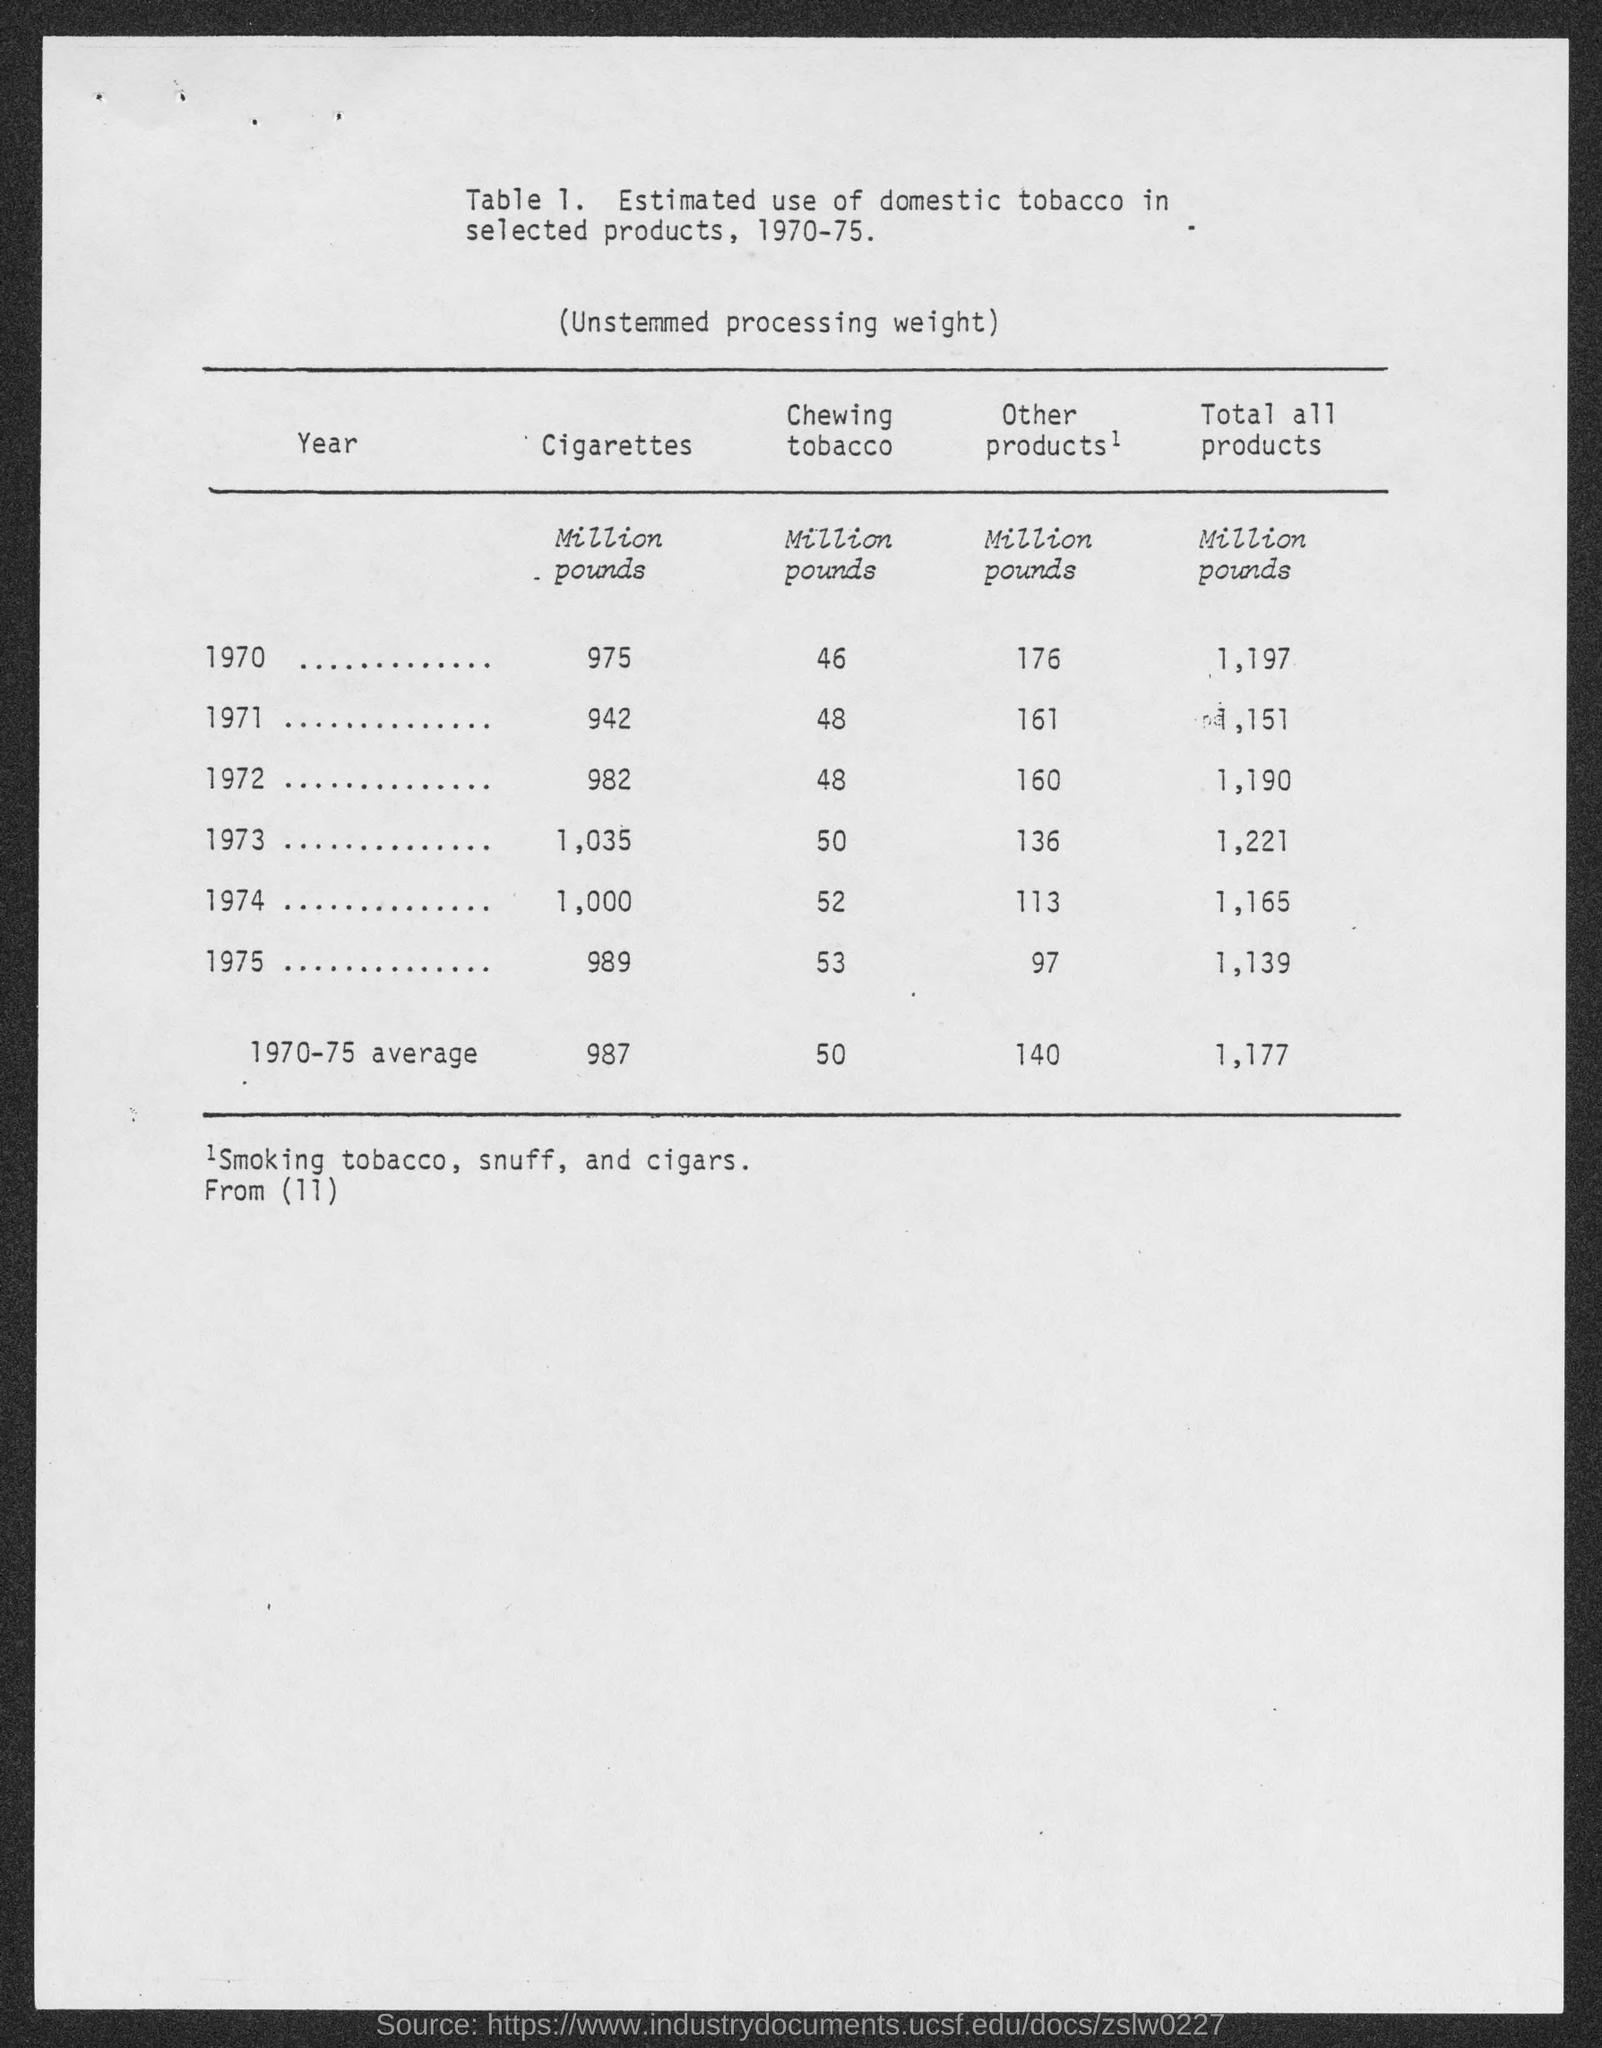What is the range of years as shown in the Title of the table?
Make the answer very short. 1970-75. How many million pounds of "Cigarettes" are estimated to be used in the year 1970?
Provide a short and direct response. 975. How many million pounds of "Chewing tobacco" are estimated to be used in the year 1971?
Ensure brevity in your answer.  48. What are the "Other products", as mentioned beneath the table?
Offer a very short reply. Smoking tobacco, snuff, and cigars. How many million pounds of "Other products" are estimated to be used in the year 1973?
Your answer should be very brief. 136. What is the heading of the 5th column from left?
Make the answer very short. Total all products. How many million pounds of "Total all products" are estimated to be used in the year 1975?
Offer a terse response. 1,139. Which year has 1,000 million pounds of "Cigarettes" estimated to be used?
Your response must be concise. 1974. What is the first column heading?
Offer a very short reply. YEAR. Which year does the third row from top represent?
Ensure brevity in your answer.  1972. 